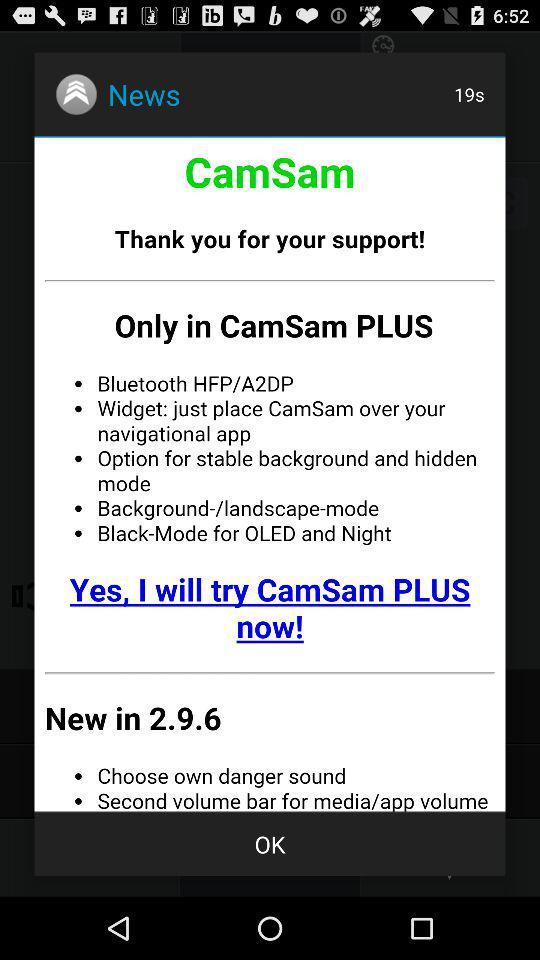What is the name of the application? The application name is "CamSam". 